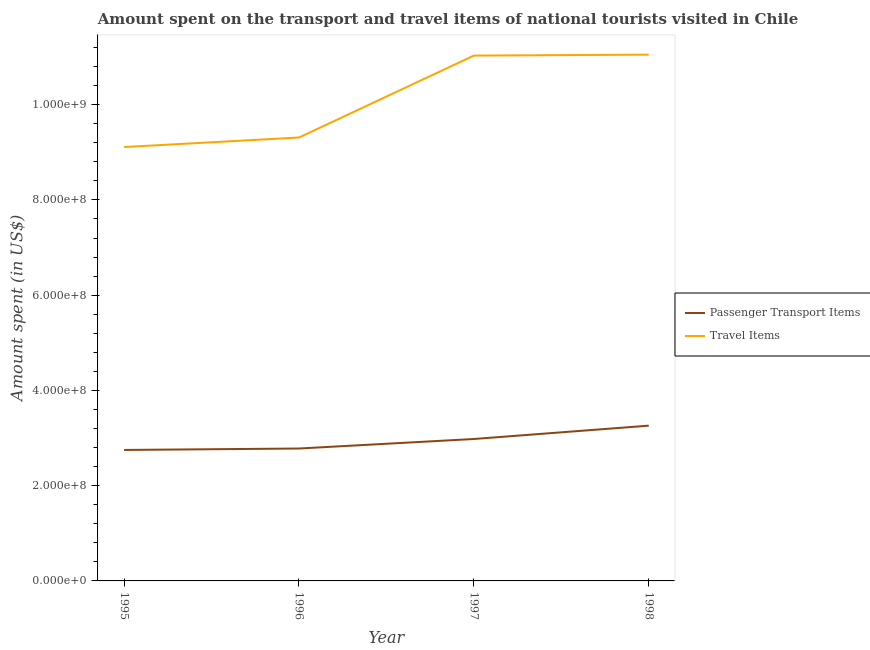Does the line corresponding to amount spent on passenger transport items intersect with the line corresponding to amount spent in travel items?
Your answer should be very brief. No. Is the number of lines equal to the number of legend labels?
Your response must be concise. Yes. What is the amount spent on passenger transport items in 1996?
Give a very brief answer. 2.78e+08. Across all years, what is the maximum amount spent on passenger transport items?
Your answer should be very brief. 3.26e+08. Across all years, what is the minimum amount spent on passenger transport items?
Your answer should be compact. 2.75e+08. In which year was the amount spent in travel items maximum?
Your response must be concise. 1998. In which year was the amount spent on passenger transport items minimum?
Your response must be concise. 1995. What is the total amount spent in travel items in the graph?
Provide a short and direct response. 4.05e+09. What is the difference between the amount spent in travel items in 1995 and that in 1998?
Your answer should be compact. -1.94e+08. What is the difference between the amount spent on passenger transport items in 1998 and the amount spent in travel items in 1996?
Your response must be concise. -6.05e+08. What is the average amount spent on passenger transport items per year?
Give a very brief answer. 2.94e+08. In the year 1995, what is the difference between the amount spent on passenger transport items and amount spent in travel items?
Your answer should be very brief. -6.36e+08. In how many years, is the amount spent in travel items greater than 800000000 US$?
Provide a succinct answer. 4. What is the ratio of the amount spent on passenger transport items in 1996 to that in 1997?
Make the answer very short. 0.93. Is the amount spent on passenger transport items in 1995 less than that in 1997?
Your response must be concise. Yes. Is the difference between the amount spent on passenger transport items in 1995 and 1998 greater than the difference between the amount spent in travel items in 1995 and 1998?
Your answer should be compact. Yes. What is the difference between the highest and the second highest amount spent in travel items?
Ensure brevity in your answer.  2.00e+06. What is the difference between the highest and the lowest amount spent in travel items?
Your answer should be compact. 1.94e+08. In how many years, is the amount spent on passenger transport items greater than the average amount spent on passenger transport items taken over all years?
Your answer should be compact. 2. Does the amount spent on passenger transport items monotonically increase over the years?
Ensure brevity in your answer.  Yes. Is the amount spent in travel items strictly greater than the amount spent on passenger transport items over the years?
Offer a very short reply. Yes. Is the amount spent in travel items strictly less than the amount spent on passenger transport items over the years?
Your answer should be compact. No. How many lines are there?
Your response must be concise. 2. Does the graph contain any zero values?
Offer a terse response. No. Does the graph contain grids?
Your answer should be compact. No. How many legend labels are there?
Your response must be concise. 2. What is the title of the graph?
Offer a terse response. Amount spent on the transport and travel items of national tourists visited in Chile. What is the label or title of the X-axis?
Keep it short and to the point. Year. What is the label or title of the Y-axis?
Provide a succinct answer. Amount spent (in US$). What is the Amount spent (in US$) in Passenger Transport Items in 1995?
Offer a very short reply. 2.75e+08. What is the Amount spent (in US$) in Travel Items in 1995?
Provide a short and direct response. 9.11e+08. What is the Amount spent (in US$) of Passenger Transport Items in 1996?
Your answer should be compact. 2.78e+08. What is the Amount spent (in US$) in Travel Items in 1996?
Ensure brevity in your answer.  9.31e+08. What is the Amount spent (in US$) of Passenger Transport Items in 1997?
Provide a short and direct response. 2.98e+08. What is the Amount spent (in US$) in Travel Items in 1997?
Provide a succinct answer. 1.10e+09. What is the Amount spent (in US$) in Passenger Transport Items in 1998?
Your answer should be very brief. 3.26e+08. What is the Amount spent (in US$) of Travel Items in 1998?
Your response must be concise. 1.10e+09. Across all years, what is the maximum Amount spent (in US$) of Passenger Transport Items?
Offer a very short reply. 3.26e+08. Across all years, what is the maximum Amount spent (in US$) in Travel Items?
Make the answer very short. 1.10e+09. Across all years, what is the minimum Amount spent (in US$) of Passenger Transport Items?
Provide a succinct answer. 2.75e+08. Across all years, what is the minimum Amount spent (in US$) of Travel Items?
Provide a succinct answer. 9.11e+08. What is the total Amount spent (in US$) of Passenger Transport Items in the graph?
Provide a succinct answer. 1.18e+09. What is the total Amount spent (in US$) in Travel Items in the graph?
Your response must be concise. 4.05e+09. What is the difference between the Amount spent (in US$) in Passenger Transport Items in 1995 and that in 1996?
Offer a very short reply. -3.00e+06. What is the difference between the Amount spent (in US$) of Travel Items in 1995 and that in 1996?
Provide a short and direct response. -2.00e+07. What is the difference between the Amount spent (in US$) of Passenger Transport Items in 1995 and that in 1997?
Keep it short and to the point. -2.30e+07. What is the difference between the Amount spent (in US$) of Travel Items in 1995 and that in 1997?
Offer a terse response. -1.92e+08. What is the difference between the Amount spent (in US$) of Passenger Transport Items in 1995 and that in 1998?
Provide a short and direct response. -5.10e+07. What is the difference between the Amount spent (in US$) of Travel Items in 1995 and that in 1998?
Offer a terse response. -1.94e+08. What is the difference between the Amount spent (in US$) in Passenger Transport Items in 1996 and that in 1997?
Provide a short and direct response. -2.00e+07. What is the difference between the Amount spent (in US$) in Travel Items in 1996 and that in 1997?
Your response must be concise. -1.72e+08. What is the difference between the Amount spent (in US$) of Passenger Transport Items in 1996 and that in 1998?
Provide a succinct answer. -4.80e+07. What is the difference between the Amount spent (in US$) in Travel Items in 1996 and that in 1998?
Your answer should be very brief. -1.74e+08. What is the difference between the Amount spent (in US$) of Passenger Transport Items in 1997 and that in 1998?
Your response must be concise. -2.80e+07. What is the difference between the Amount spent (in US$) of Passenger Transport Items in 1995 and the Amount spent (in US$) of Travel Items in 1996?
Offer a terse response. -6.56e+08. What is the difference between the Amount spent (in US$) of Passenger Transport Items in 1995 and the Amount spent (in US$) of Travel Items in 1997?
Ensure brevity in your answer.  -8.28e+08. What is the difference between the Amount spent (in US$) of Passenger Transport Items in 1995 and the Amount spent (in US$) of Travel Items in 1998?
Give a very brief answer. -8.30e+08. What is the difference between the Amount spent (in US$) of Passenger Transport Items in 1996 and the Amount spent (in US$) of Travel Items in 1997?
Provide a short and direct response. -8.25e+08. What is the difference between the Amount spent (in US$) in Passenger Transport Items in 1996 and the Amount spent (in US$) in Travel Items in 1998?
Ensure brevity in your answer.  -8.27e+08. What is the difference between the Amount spent (in US$) in Passenger Transport Items in 1997 and the Amount spent (in US$) in Travel Items in 1998?
Your response must be concise. -8.07e+08. What is the average Amount spent (in US$) in Passenger Transport Items per year?
Your answer should be compact. 2.94e+08. What is the average Amount spent (in US$) of Travel Items per year?
Offer a terse response. 1.01e+09. In the year 1995, what is the difference between the Amount spent (in US$) of Passenger Transport Items and Amount spent (in US$) of Travel Items?
Give a very brief answer. -6.36e+08. In the year 1996, what is the difference between the Amount spent (in US$) of Passenger Transport Items and Amount spent (in US$) of Travel Items?
Offer a very short reply. -6.53e+08. In the year 1997, what is the difference between the Amount spent (in US$) of Passenger Transport Items and Amount spent (in US$) of Travel Items?
Ensure brevity in your answer.  -8.05e+08. In the year 1998, what is the difference between the Amount spent (in US$) in Passenger Transport Items and Amount spent (in US$) in Travel Items?
Give a very brief answer. -7.79e+08. What is the ratio of the Amount spent (in US$) of Passenger Transport Items in 1995 to that in 1996?
Make the answer very short. 0.99. What is the ratio of the Amount spent (in US$) of Travel Items in 1995 to that in 1996?
Provide a short and direct response. 0.98. What is the ratio of the Amount spent (in US$) of Passenger Transport Items in 1995 to that in 1997?
Your answer should be very brief. 0.92. What is the ratio of the Amount spent (in US$) of Travel Items in 1995 to that in 1997?
Your answer should be very brief. 0.83. What is the ratio of the Amount spent (in US$) of Passenger Transport Items in 1995 to that in 1998?
Make the answer very short. 0.84. What is the ratio of the Amount spent (in US$) of Travel Items in 1995 to that in 1998?
Give a very brief answer. 0.82. What is the ratio of the Amount spent (in US$) of Passenger Transport Items in 1996 to that in 1997?
Provide a succinct answer. 0.93. What is the ratio of the Amount spent (in US$) of Travel Items in 1996 to that in 1997?
Provide a succinct answer. 0.84. What is the ratio of the Amount spent (in US$) in Passenger Transport Items in 1996 to that in 1998?
Give a very brief answer. 0.85. What is the ratio of the Amount spent (in US$) of Travel Items in 1996 to that in 1998?
Keep it short and to the point. 0.84. What is the ratio of the Amount spent (in US$) of Passenger Transport Items in 1997 to that in 1998?
Provide a succinct answer. 0.91. What is the difference between the highest and the second highest Amount spent (in US$) of Passenger Transport Items?
Provide a short and direct response. 2.80e+07. What is the difference between the highest and the lowest Amount spent (in US$) in Passenger Transport Items?
Your answer should be compact. 5.10e+07. What is the difference between the highest and the lowest Amount spent (in US$) of Travel Items?
Your answer should be very brief. 1.94e+08. 